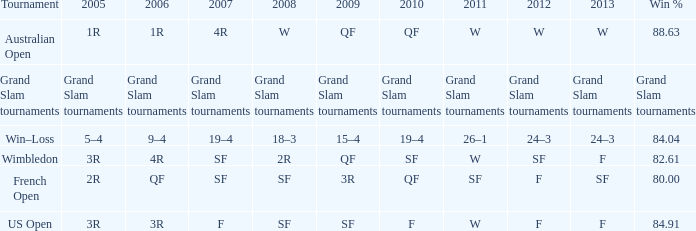Which Tournament has a 2007 of 19–4? Win–Loss. 